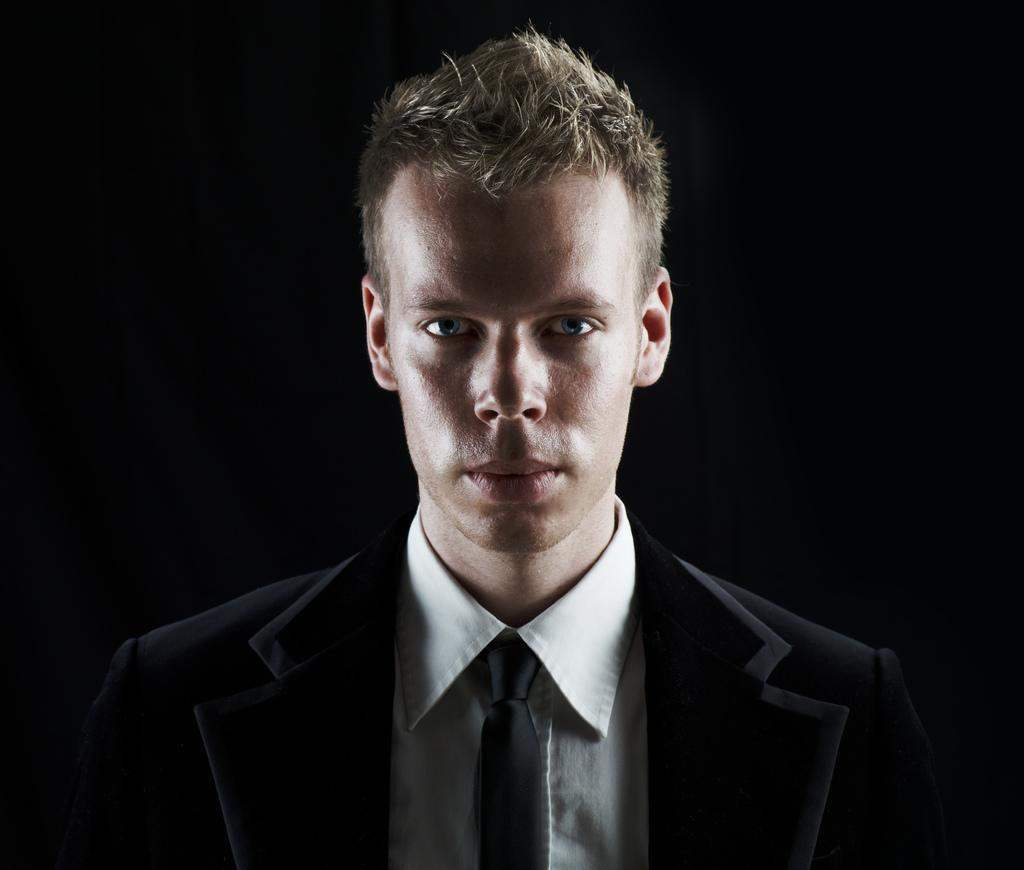Who is the main subject in the image? There is a man in the image. What is the man wearing? The man is wearing a black and white suit. Who or what is the man looking at? The man is looking at someone. What can be observed about the background of the image? The background of the image is dark. What type of jewel is the man kicking in the image? There is no jewel present in the image, nor is the man kicking anything. 